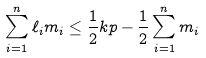Convert formula to latex. <formula><loc_0><loc_0><loc_500><loc_500>\sum _ { i = 1 } ^ { n } \ell _ { i } m _ { i } \leq \frac { 1 } { 2 } k p - \frac { 1 } { 2 } \sum _ { i = 1 } ^ { n } m _ { i }</formula> 